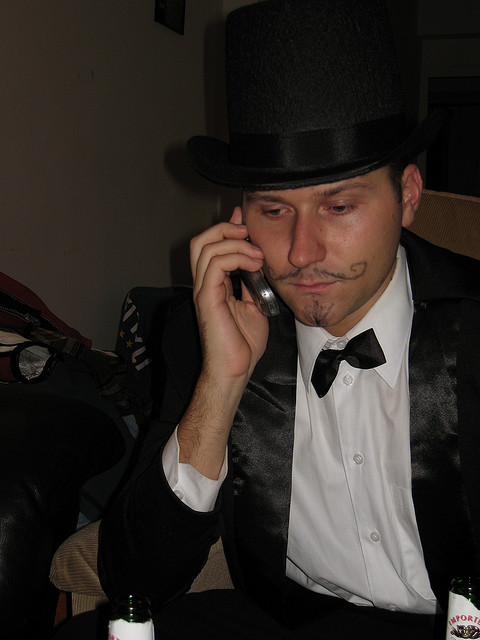What event or occasion might the person in the image be attending, based on their attire? Given the individual's attire, which includes a formal black suit, a top hat, and what appears to be a fake mustache, it's plausible that the person might be attending a themed party or event, possibly with a costume or historical component. 